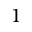Convert formula to latex. <formula><loc_0><loc_0><loc_500><loc_500>1</formula> 